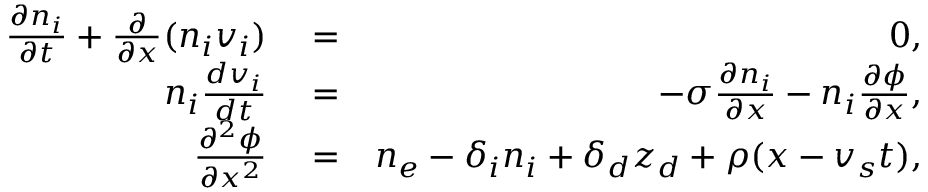<formula> <loc_0><loc_0><loc_500><loc_500>\begin{array} { r l r } { \frac { \partial n _ { i } } { \partial t } + \frac { \partial } { \partial x } ( n _ { i } v _ { i } ) } & = } & { 0 , } \\ { n _ { i } \frac { d v _ { i } } { d t } } & = } & { - \sigma \frac { \partial n _ { i } } { \partial x } - n _ { i } \frac { \partial \phi } { \partial x } , } \\ { \frac { \partial ^ { 2 } \phi } { \partial x ^ { 2 } } } & = } & { n _ { e } - \delta _ { i } n _ { i } + \delta _ { d } z _ { d } + \rho ( x - v _ { s } t ) , } \end{array}</formula> 